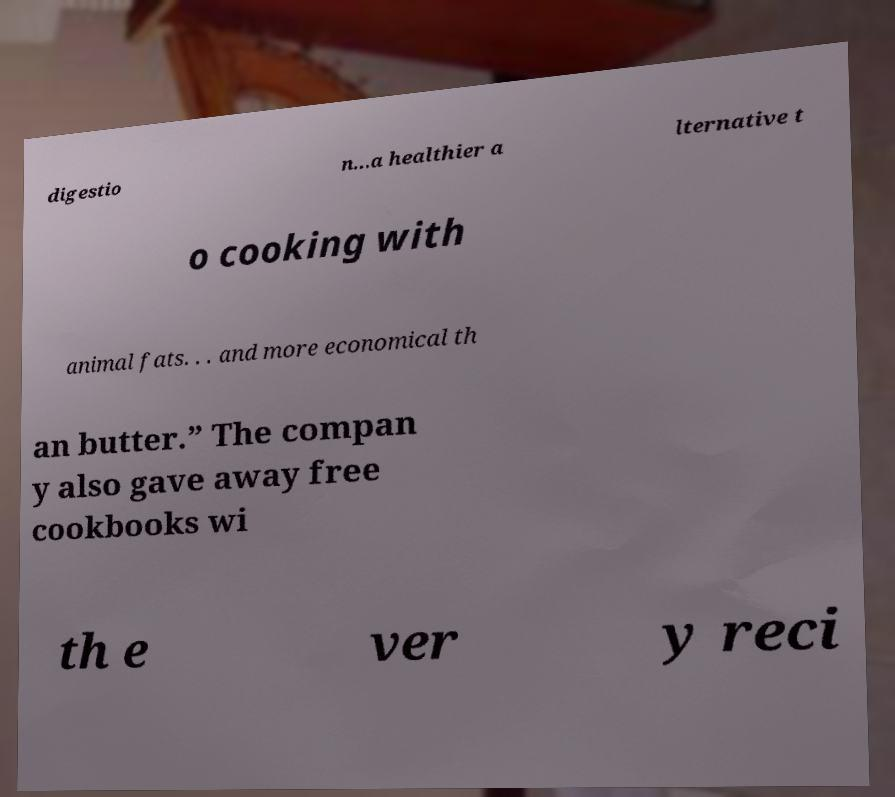Could you assist in decoding the text presented in this image and type it out clearly? digestio n...a healthier a lternative t o cooking with animal fats. . . and more economical th an butter.” The compan y also gave away free cookbooks wi th e ver y reci 